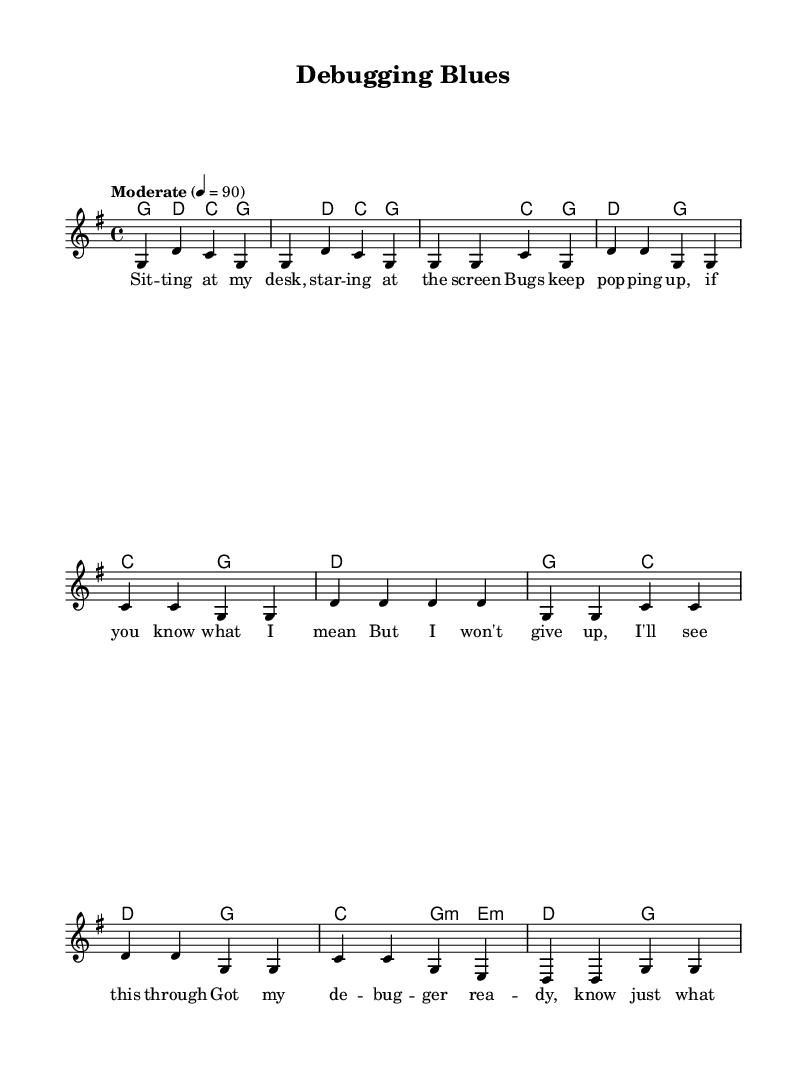What is the key signature of this music? The key signature is G major, indicated by one sharp. You can find the key signature at the beginning of the staff section.
Answer: G major What is the time signature of the piece? The time signature is four-four, which can be found at the beginning of the score, specifying that there are four beats in each measure.
Answer: Four-four What is the tempo marking for this piece? The tempo marking is 'Moderate', which indicates the speed of the song. This is indicated at the beginning of the score.
Answer: Moderate How many measures are in the verse? The verse consists of four measures, as can be counted in the melody section where the lyrics begin.
Answer: Four Which chord is used in the chorus? The chorus includes C major and G major, as seen in the chord progression indicated in the harmonies section of the music.
Answer: C major What theme do the lyrics express? The lyrics express themes of perseverance and problem-solving, focusing on overcoming challenges in debugging and coding. This is found in the context of the lyrics provided.
Answer: Perseverance What style of music does this piece represent? This piece represents the Folk genre, which is characterized by its storytelling elements and relatable themes, as highlighted in the lyrical content and simplicity of the arrangement.
Answer: Folk 